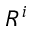Convert formula to latex. <formula><loc_0><loc_0><loc_500><loc_500>R ^ { i }</formula> 